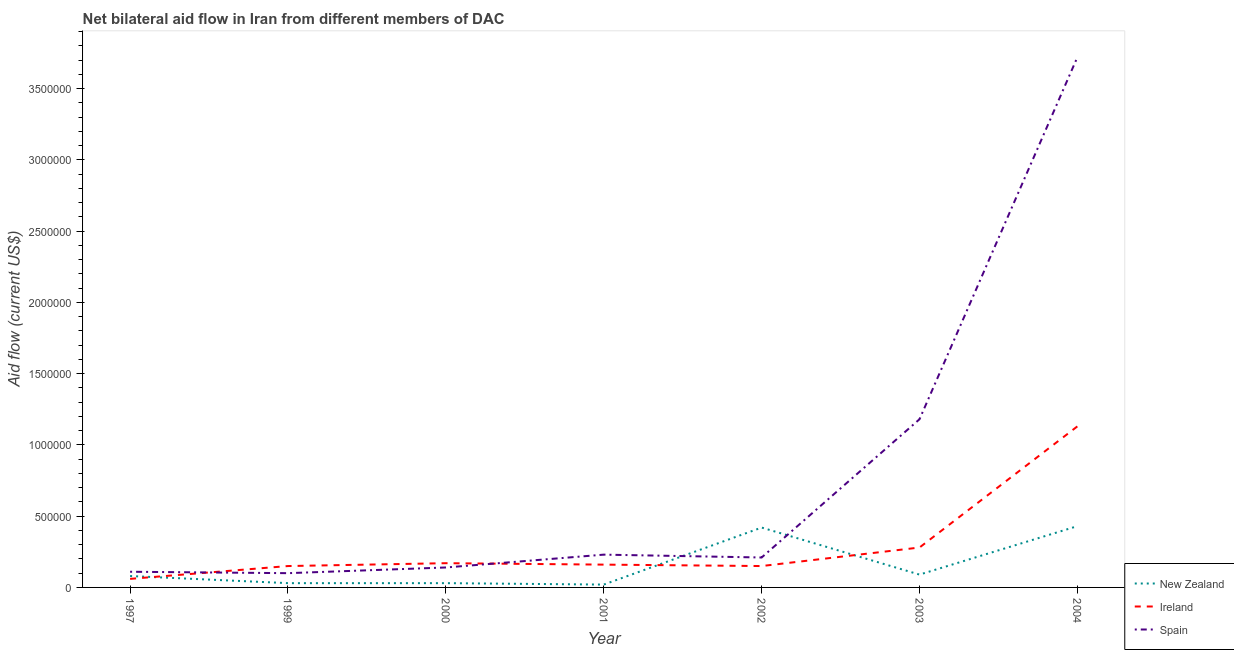How many different coloured lines are there?
Your response must be concise. 3. Does the line corresponding to amount of aid provided by ireland intersect with the line corresponding to amount of aid provided by spain?
Make the answer very short. Yes. What is the amount of aid provided by ireland in 1999?
Provide a succinct answer. 1.50e+05. Across all years, what is the maximum amount of aid provided by new zealand?
Ensure brevity in your answer.  4.30e+05. Across all years, what is the minimum amount of aid provided by new zealand?
Offer a terse response. 2.00e+04. In which year was the amount of aid provided by ireland minimum?
Your answer should be compact. 1997. What is the total amount of aid provided by ireland in the graph?
Offer a very short reply. 2.10e+06. What is the difference between the amount of aid provided by spain in 1997 and that in 2000?
Give a very brief answer. -3.00e+04. What is the difference between the amount of aid provided by new zealand in 1997 and the amount of aid provided by ireland in 2002?
Provide a short and direct response. -7.00e+04. What is the average amount of aid provided by new zealand per year?
Keep it short and to the point. 1.57e+05. In the year 2001, what is the difference between the amount of aid provided by new zealand and amount of aid provided by spain?
Provide a short and direct response. -2.10e+05. In how many years, is the amount of aid provided by ireland greater than 200000 US$?
Your response must be concise. 2. What is the ratio of the amount of aid provided by spain in 1999 to that in 2002?
Offer a terse response. 0.48. Is the amount of aid provided by ireland in 1999 less than that in 2000?
Ensure brevity in your answer.  Yes. Is the difference between the amount of aid provided by ireland in 1999 and 2004 greater than the difference between the amount of aid provided by spain in 1999 and 2004?
Offer a very short reply. Yes. What is the difference between the highest and the second highest amount of aid provided by spain?
Give a very brief answer. 2.54e+06. What is the difference between the highest and the lowest amount of aid provided by ireland?
Keep it short and to the point. 1.07e+06. Is the sum of the amount of aid provided by new zealand in 2000 and 2002 greater than the maximum amount of aid provided by spain across all years?
Your answer should be very brief. No. Does the amount of aid provided by ireland monotonically increase over the years?
Ensure brevity in your answer.  No. Is the amount of aid provided by new zealand strictly less than the amount of aid provided by spain over the years?
Your answer should be compact. No. Does the graph contain any zero values?
Your answer should be compact. No. Does the graph contain grids?
Keep it short and to the point. No. Where does the legend appear in the graph?
Keep it short and to the point. Bottom right. How many legend labels are there?
Offer a very short reply. 3. What is the title of the graph?
Keep it short and to the point. Net bilateral aid flow in Iran from different members of DAC. Does "Ireland" appear as one of the legend labels in the graph?
Your response must be concise. Yes. What is the label or title of the Y-axis?
Keep it short and to the point. Aid flow (current US$). What is the Aid flow (current US$) of New Zealand in 1997?
Offer a terse response. 8.00e+04. What is the Aid flow (current US$) of Ireland in 1997?
Give a very brief answer. 6.00e+04. What is the Aid flow (current US$) of Ireland in 1999?
Provide a succinct answer. 1.50e+05. What is the Aid flow (current US$) of Spain in 1999?
Your answer should be very brief. 1.00e+05. What is the Aid flow (current US$) in New Zealand in 2001?
Your response must be concise. 2.00e+04. What is the Aid flow (current US$) of Ireland in 2001?
Your answer should be compact. 1.60e+05. What is the Aid flow (current US$) of New Zealand in 2002?
Your response must be concise. 4.20e+05. What is the Aid flow (current US$) of Ireland in 2002?
Offer a terse response. 1.50e+05. What is the Aid flow (current US$) of Spain in 2002?
Make the answer very short. 2.10e+05. What is the Aid flow (current US$) of New Zealand in 2003?
Your response must be concise. 9.00e+04. What is the Aid flow (current US$) of Ireland in 2003?
Make the answer very short. 2.80e+05. What is the Aid flow (current US$) in Spain in 2003?
Ensure brevity in your answer.  1.18e+06. What is the Aid flow (current US$) of Ireland in 2004?
Provide a short and direct response. 1.13e+06. What is the Aid flow (current US$) in Spain in 2004?
Your response must be concise. 3.72e+06. Across all years, what is the maximum Aid flow (current US$) of New Zealand?
Offer a very short reply. 4.30e+05. Across all years, what is the maximum Aid flow (current US$) in Ireland?
Provide a succinct answer. 1.13e+06. Across all years, what is the maximum Aid flow (current US$) in Spain?
Your response must be concise. 3.72e+06. Across all years, what is the minimum Aid flow (current US$) of Ireland?
Offer a terse response. 6.00e+04. What is the total Aid flow (current US$) in New Zealand in the graph?
Provide a short and direct response. 1.10e+06. What is the total Aid flow (current US$) of Ireland in the graph?
Give a very brief answer. 2.10e+06. What is the total Aid flow (current US$) in Spain in the graph?
Keep it short and to the point. 5.69e+06. What is the difference between the Aid flow (current US$) in Ireland in 1997 and that in 1999?
Your answer should be very brief. -9.00e+04. What is the difference between the Aid flow (current US$) of New Zealand in 1997 and that in 2000?
Your answer should be very brief. 5.00e+04. What is the difference between the Aid flow (current US$) of Spain in 1997 and that in 2000?
Your answer should be very brief. -3.00e+04. What is the difference between the Aid flow (current US$) of New Zealand in 1997 and that in 2001?
Give a very brief answer. 6.00e+04. What is the difference between the Aid flow (current US$) in Ireland in 1997 and that in 2001?
Offer a very short reply. -1.00e+05. What is the difference between the Aid flow (current US$) of Spain in 1997 and that in 2001?
Offer a terse response. -1.20e+05. What is the difference between the Aid flow (current US$) of Spain in 1997 and that in 2002?
Give a very brief answer. -1.00e+05. What is the difference between the Aid flow (current US$) of Ireland in 1997 and that in 2003?
Provide a short and direct response. -2.20e+05. What is the difference between the Aid flow (current US$) of Spain in 1997 and that in 2003?
Your answer should be very brief. -1.07e+06. What is the difference between the Aid flow (current US$) in New Zealand in 1997 and that in 2004?
Keep it short and to the point. -3.50e+05. What is the difference between the Aid flow (current US$) in Ireland in 1997 and that in 2004?
Offer a terse response. -1.07e+06. What is the difference between the Aid flow (current US$) in Spain in 1997 and that in 2004?
Ensure brevity in your answer.  -3.61e+06. What is the difference between the Aid flow (current US$) in New Zealand in 1999 and that in 2000?
Your answer should be compact. 0. What is the difference between the Aid flow (current US$) of Ireland in 1999 and that in 2000?
Offer a very short reply. -2.00e+04. What is the difference between the Aid flow (current US$) in Spain in 1999 and that in 2000?
Provide a short and direct response. -4.00e+04. What is the difference between the Aid flow (current US$) in New Zealand in 1999 and that in 2001?
Your answer should be very brief. 10000. What is the difference between the Aid flow (current US$) of Spain in 1999 and that in 2001?
Give a very brief answer. -1.30e+05. What is the difference between the Aid flow (current US$) of New Zealand in 1999 and that in 2002?
Your answer should be compact. -3.90e+05. What is the difference between the Aid flow (current US$) of Ireland in 1999 and that in 2002?
Your answer should be very brief. 0. What is the difference between the Aid flow (current US$) in Spain in 1999 and that in 2002?
Your answer should be very brief. -1.10e+05. What is the difference between the Aid flow (current US$) of New Zealand in 1999 and that in 2003?
Keep it short and to the point. -6.00e+04. What is the difference between the Aid flow (current US$) of Spain in 1999 and that in 2003?
Your answer should be compact. -1.08e+06. What is the difference between the Aid flow (current US$) in New Zealand in 1999 and that in 2004?
Offer a very short reply. -4.00e+05. What is the difference between the Aid flow (current US$) in Ireland in 1999 and that in 2004?
Your answer should be very brief. -9.80e+05. What is the difference between the Aid flow (current US$) in Spain in 1999 and that in 2004?
Give a very brief answer. -3.62e+06. What is the difference between the Aid flow (current US$) of Ireland in 2000 and that in 2001?
Offer a very short reply. 10000. What is the difference between the Aid flow (current US$) of Spain in 2000 and that in 2001?
Your answer should be very brief. -9.00e+04. What is the difference between the Aid flow (current US$) of New Zealand in 2000 and that in 2002?
Your response must be concise. -3.90e+05. What is the difference between the Aid flow (current US$) of New Zealand in 2000 and that in 2003?
Provide a short and direct response. -6.00e+04. What is the difference between the Aid flow (current US$) of Ireland in 2000 and that in 2003?
Provide a short and direct response. -1.10e+05. What is the difference between the Aid flow (current US$) in Spain in 2000 and that in 2003?
Keep it short and to the point. -1.04e+06. What is the difference between the Aid flow (current US$) in New Zealand in 2000 and that in 2004?
Give a very brief answer. -4.00e+05. What is the difference between the Aid flow (current US$) in Ireland in 2000 and that in 2004?
Ensure brevity in your answer.  -9.60e+05. What is the difference between the Aid flow (current US$) in Spain in 2000 and that in 2004?
Provide a short and direct response. -3.58e+06. What is the difference between the Aid flow (current US$) in New Zealand in 2001 and that in 2002?
Your answer should be very brief. -4.00e+05. What is the difference between the Aid flow (current US$) of Ireland in 2001 and that in 2003?
Give a very brief answer. -1.20e+05. What is the difference between the Aid flow (current US$) of Spain in 2001 and that in 2003?
Provide a succinct answer. -9.50e+05. What is the difference between the Aid flow (current US$) of New Zealand in 2001 and that in 2004?
Provide a succinct answer. -4.10e+05. What is the difference between the Aid flow (current US$) of Ireland in 2001 and that in 2004?
Your answer should be very brief. -9.70e+05. What is the difference between the Aid flow (current US$) of Spain in 2001 and that in 2004?
Give a very brief answer. -3.49e+06. What is the difference between the Aid flow (current US$) in New Zealand in 2002 and that in 2003?
Your answer should be very brief. 3.30e+05. What is the difference between the Aid flow (current US$) of Spain in 2002 and that in 2003?
Ensure brevity in your answer.  -9.70e+05. What is the difference between the Aid flow (current US$) in Ireland in 2002 and that in 2004?
Give a very brief answer. -9.80e+05. What is the difference between the Aid flow (current US$) of Spain in 2002 and that in 2004?
Provide a short and direct response. -3.51e+06. What is the difference between the Aid flow (current US$) of New Zealand in 2003 and that in 2004?
Your answer should be compact. -3.40e+05. What is the difference between the Aid flow (current US$) in Ireland in 2003 and that in 2004?
Provide a short and direct response. -8.50e+05. What is the difference between the Aid flow (current US$) of Spain in 2003 and that in 2004?
Provide a succinct answer. -2.54e+06. What is the difference between the Aid flow (current US$) in New Zealand in 1997 and the Aid flow (current US$) in Spain in 2000?
Offer a terse response. -6.00e+04. What is the difference between the Aid flow (current US$) of New Zealand in 1997 and the Aid flow (current US$) of Spain in 2001?
Offer a very short reply. -1.50e+05. What is the difference between the Aid flow (current US$) in New Zealand in 1997 and the Aid flow (current US$) in Ireland in 2002?
Your response must be concise. -7.00e+04. What is the difference between the Aid flow (current US$) of New Zealand in 1997 and the Aid flow (current US$) of Ireland in 2003?
Keep it short and to the point. -2.00e+05. What is the difference between the Aid flow (current US$) in New Zealand in 1997 and the Aid flow (current US$) in Spain in 2003?
Provide a succinct answer. -1.10e+06. What is the difference between the Aid flow (current US$) of Ireland in 1997 and the Aid flow (current US$) of Spain in 2003?
Offer a terse response. -1.12e+06. What is the difference between the Aid flow (current US$) in New Zealand in 1997 and the Aid flow (current US$) in Ireland in 2004?
Your answer should be very brief. -1.05e+06. What is the difference between the Aid flow (current US$) of New Zealand in 1997 and the Aid flow (current US$) of Spain in 2004?
Keep it short and to the point. -3.64e+06. What is the difference between the Aid flow (current US$) of Ireland in 1997 and the Aid flow (current US$) of Spain in 2004?
Your answer should be compact. -3.66e+06. What is the difference between the Aid flow (current US$) of Ireland in 1999 and the Aid flow (current US$) of Spain in 2000?
Your answer should be compact. 10000. What is the difference between the Aid flow (current US$) in New Zealand in 1999 and the Aid flow (current US$) in Ireland in 2001?
Provide a short and direct response. -1.30e+05. What is the difference between the Aid flow (current US$) of New Zealand in 1999 and the Aid flow (current US$) of Spain in 2001?
Provide a short and direct response. -2.00e+05. What is the difference between the Aid flow (current US$) of New Zealand in 1999 and the Aid flow (current US$) of Ireland in 2002?
Provide a succinct answer. -1.20e+05. What is the difference between the Aid flow (current US$) in Ireland in 1999 and the Aid flow (current US$) in Spain in 2002?
Keep it short and to the point. -6.00e+04. What is the difference between the Aid flow (current US$) of New Zealand in 1999 and the Aid flow (current US$) of Spain in 2003?
Offer a very short reply. -1.15e+06. What is the difference between the Aid flow (current US$) in Ireland in 1999 and the Aid flow (current US$) in Spain in 2003?
Offer a very short reply. -1.03e+06. What is the difference between the Aid flow (current US$) of New Zealand in 1999 and the Aid flow (current US$) of Ireland in 2004?
Keep it short and to the point. -1.10e+06. What is the difference between the Aid flow (current US$) in New Zealand in 1999 and the Aid flow (current US$) in Spain in 2004?
Offer a terse response. -3.69e+06. What is the difference between the Aid flow (current US$) of Ireland in 1999 and the Aid flow (current US$) of Spain in 2004?
Offer a very short reply. -3.57e+06. What is the difference between the Aid flow (current US$) in New Zealand in 2000 and the Aid flow (current US$) in Spain in 2001?
Make the answer very short. -2.00e+05. What is the difference between the Aid flow (current US$) in Ireland in 2000 and the Aid flow (current US$) in Spain in 2002?
Make the answer very short. -4.00e+04. What is the difference between the Aid flow (current US$) of New Zealand in 2000 and the Aid flow (current US$) of Ireland in 2003?
Provide a succinct answer. -2.50e+05. What is the difference between the Aid flow (current US$) of New Zealand in 2000 and the Aid flow (current US$) of Spain in 2003?
Your answer should be very brief. -1.15e+06. What is the difference between the Aid flow (current US$) of Ireland in 2000 and the Aid flow (current US$) of Spain in 2003?
Offer a terse response. -1.01e+06. What is the difference between the Aid flow (current US$) of New Zealand in 2000 and the Aid flow (current US$) of Ireland in 2004?
Offer a terse response. -1.10e+06. What is the difference between the Aid flow (current US$) in New Zealand in 2000 and the Aid flow (current US$) in Spain in 2004?
Your answer should be very brief. -3.69e+06. What is the difference between the Aid flow (current US$) in Ireland in 2000 and the Aid flow (current US$) in Spain in 2004?
Your response must be concise. -3.55e+06. What is the difference between the Aid flow (current US$) in New Zealand in 2001 and the Aid flow (current US$) in Ireland in 2002?
Keep it short and to the point. -1.30e+05. What is the difference between the Aid flow (current US$) of New Zealand in 2001 and the Aid flow (current US$) of Spain in 2002?
Make the answer very short. -1.90e+05. What is the difference between the Aid flow (current US$) of Ireland in 2001 and the Aid flow (current US$) of Spain in 2002?
Give a very brief answer. -5.00e+04. What is the difference between the Aid flow (current US$) in New Zealand in 2001 and the Aid flow (current US$) in Spain in 2003?
Ensure brevity in your answer.  -1.16e+06. What is the difference between the Aid flow (current US$) in Ireland in 2001 and the Aid flow (current US$) in Spain in 2003?
Offer a terse response. -1.02e+06. What is the difference between the Aid flow (current US$) in New Zealand in 2001 and the Aid flow (current US$) in Ireland in 2004?
Keep it short and to the point. -1.11e+06. What is the difference between the Aid flow (current US$) in New Zealand in 2001 and the Aid flow (current US$) in Spain in 2004?
Your response must be concise. -3.70e+06. What is the difference between the Aid flow (current US$) in Ireland in 2001 and the Aid flow (current US$) in Spain in 2004?
Offer a terse response. -3.56e+06. What is the difference between the Aid flow (current US$) in New Zealand in 2002 and the Aid flow (current US$) in Spain in 2003?
Give a very brief answer. -7.60e+05. What is the difference between the Aid flow (current US$) in Ireland in 2002 and the Aid flow (current US$) in Spain in 2003?
Give a very brief answer. -1.03e+06. What is the difference between the Aid flow (current US$) in New Zealand in 2002 and the Aid flow (current US$) in Ireland in 2004?
Offer a terse response. -7.10e+05. What is the difference between the Aid flow (current US$) in New Zealand in 2002 and the Aid flow (current US$) in Spain in 2004?
Make the answer very short. -3.30e+06. What is the difference between the Aid flow (current US$) of Ireland in 2002 and the Aid flow (current US$) of Spain in 2004?
Your answer should be compact. -3.57e+06. What is the difference between the Aid flow (current US$) of New Zealand in 2003 and the Aid flow (current US$) of Ireland in 2004?
Ensure brevity in your answer.  -1.04e+06. What is the difference between the Aid flow (current US$) in New Zealand in 2003 and the Aid flow (current US$) in Spain in 2004?
Keep it short and to the point. -3.63e+06. What is the difference between the Aid flow (current US$) in Ireland in 2003 and the Aid flow (current US$) in Spain in 2004?
Provide a succinct answer. -3.44e+06. What is the average Aid flow (current US$) in New Zealand per year?
Ensure brevity in your answer.  1.57e+05. What is the average Aid flow (current US$) of Ireland per year?
Give a very brief answer. 3.00e+05. What is the average Aid flow (current US$) in Spain per year?
Provide a succinct answer. 8.13e+05. In the year 1997, what is the difference between the Aid flow (current US$) in New Zealand and Aid flow (current US$) in Spain?
Your answer should be compact. -3.00e+04. In the year 1997, what is the difference between the Aid flow (current US$) of Ireland and Aid flow (current US$) of Spain?
Give a very brief answer. -5.00e+04. In the year 2000, what is the difference between the Aid flow (current US$) in New Zealand and Aid flow (current US$) in Spain?
Ensure brevity in your answer.  -1.10e+05. In the year 2000, what is the difference between the Aid flow (current US$) of Ireland and Aid flow (current US$) of Spain?
Offer a terse response. 3.00e+04. In the year 2001, what is the difference between the Aid flow (current US$) in New Zealand and Aid flow (current US$) in Spain?
Make the answer very short. -2.10e+05. In the year 2002, what is the difference between the Aid flow (current US$) of New Zealand and Aid flow (current US$) of Spain?
Offer a terse response. 2.10e+05. In the year 2003, what is the difference between the Aid flow (current US$) of New Zealand and Aid flow (current US$) of Ireland?
Make the answer very short. -1.90e+05. In the year 2003, what is the difference between the Aid flow (current US$) in New Zealand and Aid flow (current US$) in Spain?
Provide a succinct answer. -1.09e+06. In the year 2003, what is the difference between the Aid flow (current US$) in Ireland and Aid flow (current US$) in Spain?
Your response must be concise. -9.00e+05. In the year 2004, what is the difference between the Aid flow (current US$) of New Zealand and Aid flow (current US$) of Ireland?
Make the answer very short. -7.00e+05. In the year 2004, what is the difference between the Aid flow (current US$) in New Zealand and Aid flow (current US$) in Spain?
Provide a succinct answer. -3.29e+06. In the year 2004, what is the difference between the Aid flow (current US$) of Ireland and Aid flow (current US$) of Spain?
Keep it short and to the point. -2.59e+06. What is the ratio of the Aid flow (current US$) of New Zealand in 1997 to that in 1999?
Your response must be concise. 2.67. What is the ratio of the Aid flow (current US$) of Ireland in 1997 to that in 1999?
Keep it short and to the point. 0.4. What is the ratio of the Aid flow (current US$) in New Zealand in 1997 to that in 2000?
Provide a short and direct response. 2.67. What is the ratio of the Aid flow (current US$) in Ireland in 1997 to that in 2000?
Offer a very short reply. 0.35. What is the ratio of the Aid flow (current US$) of Spain in 1997 to that in 2000?
Give a very brief answer. 0.79. What is the ratio of the Aid flow (current US$) in New Zealand in 1997 to that in 2001?
Provide a short and direct response. 4. What is the ratio of the Aid flow (current US$) in Spain in 1997 to that in 2001?
Ensure brevity in your answer.  0.48. What is the ratio of the Aid flow (current US$) of New Zealand in 1997 to that in 2002?
Give a very brief answer. 0.19. What is the ratio of the Aid flow (current US$) of Spain in 1997 to that in 2002?
Offer a very short reply. 0.52. What is the ratio of the Aid flow (current US$) of New Zealand in 1997 to that in 2003?
Your response must be concise. 0.89. What is the ratio of the Aid flow (current US$) of Ireland in 1997 to that in 2003?
Offer a very short reply. 0.21. What is the ratio of the Aid flow (current US$) in Spain in 1997 to that in 2003?
Your answer should be very brief. 0.09. What is the ratio of the Aid flow (current US$) of New Zealand in 1997 to that in 2004?
Offer a terse response. 0.19. What is the ratio of the Aid flow (current US$) in Ireland in 1997 to that in 2004?
Your response must be concise. 0.05. What is the ratio of the Aid flow (current US$) in Spain in 1997 to that in 2004?
Your answer should be compact. 0.03. What is the ratio of the Aid flow (current US$) in New Zealand in 1999 to that in 2000?
Provide a succinct answer. 1. What is the ratio of the Aid flow (current US$) of Ireland in 1999 to that in 2000?
Provide a short and direct response. 0.88. What is the ratio of the Aid flow (current US$) in New Zealand in 1999 to that in 2001?
Keep it short and to the point. 1.5. What is the ratio of the Aid flow (current US$) in Ireland in 1999 to that in 2001?
Provide a succinct answer. 0.94. What is the ratio of the Aid flow (current US$) of Spain in 1999 to that in 2001?
Provide a succinct answer. 0.43. What is the ratio of the Aid flow (current US$) in New Zealand in 1999 to that in 2002?
Your answer should be very brief. 0.07. What is the ratio of the Aid flow (current US$) of Ireland in 1999 to that in 2002?
Keep it short and to the point. 1. What is the ratio of the Aid flow (current US$) of Spain in 1999 to that in 2002?
Make the answer very short. 0.48. What is the ratio of the Aid flow (current US$) in Ireland in 1999 to that in 2003?
Your answer should be very brief. 0.54. What is the ratio of the Aid flow (current US$) in Spain in 1999 to that in 2003?
Offer a terse response. 0.08. What is the ratio of the Aid flow (current US$) in New Zealand in 1999 to that in 2004?
Your response must be concise. 0.07. What is the ratio of the Aid flow (current US$) in Ireland in 1999 to that in 2004?
Ensure brevity in your answer.  0.13. What is the ratio of the Aid flow (current US$) of Spain in 1999 to that in 2004?
Your response must be concise. 0.03. What is the ratio of the Aid flow (current US$) of New Zealand in 2000 to that in 2001?
Ensure brevity in your answer.  1.5. What is the ratio of the Aid flow (current US$) in Spain in 2000 to that in 2001?
Make the answer very short. 0.61. What is the ratio of the Aid flow (current US$) in New Zealand in 2000 to that in 2002?
Ensure brevity in your answer.  0.07. What is the ratio of the Aid flow (current US$) in Ireland in 2000 to that in 2002?
Your answer should be very brief. 1.13. What is the ratio of the Aid flow (current US$) of New Zealand in 2000 to that in 2003?
Keep it short and to the point. 0.33. What is the ratio of the Aid flow (current US$) in Ireland in 2000 to that in 2003?
Offer a terse response. 0.61. What is the ratio of the Aid flow (current US$) of Spain in 2000 to that in 2003?
Provide a short and direct response. 0.12. What is the ratio of the Aid flow (current US$) in New Zealand in 2000 to that in 2004?
Provide a succinct answer. 0.07. What is the ratio of the Aid flow (current US$) of Ireland in 2000 to that in 2004?
Your answer should be compact. 0.15. What is the ratio of the Aid flow (current US$) in Spain in 2000 to that in 2004?
Your answer should be very brief. 0.04. What is the ratio of the Aid flow (current US$) in New Zealand in 2001 to that in 2002?
Provide a succinct answer. 0.05. What is the ratio of the Aid flow (current US$) of Ireland in 2001 to that in 2002?
Make the answer very short. 1.07. What is the ratio of the Aid flow (current US$) in Spain in 2001 to that in 2002?
Your answer should be compact. 1.1. What is the ratio of the Aid flow (current US$) of New Zealand in 2001 to that in 2003?
Provide a succinct answer. 0.22. What is the ratio of the Aid flow (current US$) in Spain in 2001 to that in 2003?
Provide a succinct answer. 0.19. What is the ratio of the Aid flow (current US$) of New Zealand in 2001 to that in 2004?
Provide a short and direct response. 0.05. What is the ratio of the Aid flow (current US$) of Ireland in 2001 to that in 2004?
Keep it short and to the point. 0.14. What is the ratio of the Aid flow (current US$) in Spain in 2001 to that in 2004?
Offer a terse response. 0.06. What is the ratio of the Aid flow (current US$) of New Zealand in 2002 to that in 2003?
Give a very brief answer. 4.67. What is the ratio of the Aid flow (current US$) of Ireland in 2002 to that in 2003?
Your answer should be very brief. 0.54. What is the ratio of the Aid flow (current US$) of Spain in 2002 to that in 2003?
Your response must be concise. 0.18. What is the ratio of the Aid flow (current US$) of New Zealand in 2002 to that in 2004?
Make the answer very short. 0.98. What is the ratio of the Aid flow (current US$) in Ireland in 2002 to that in 2004?
Your answer should be compact. 0.13. What is the ratio of the Aid flow (current US$) in Spain in 2002 to that in 2004?
Offer a very short reply. 0.06. What is the ratio of the Aid flow (current US$) of New Zealand in 2003 to that in 2004?
Ensure brevity in your answer.  0.21. What is the ratio of the Aid flow (current US$) in Ireland in 2003 to that in 2004?
Your response must be concise. 0.25. What is the ratio of the Aid flow (current US$) in Spain in 2003 to that in 2004?
Give a very brief answer. 0.32. What is the difference between the highest and the second highest Aid flow (current US$) in New Zealand?
Your response must be concise. 10000. What is the difference between the highest and the second highest Aid flow (current US$) of Ireland?
Make the answer very short. 8.50e+05. What is the difference between the highest and the second highest Aid flow (current US$) of Spain?
Make the answer very short. 2.54e+06. What is the difference between the highest and the lowest Aid flow (current US$) in New Zealand?
Your response must be concise. 4.10e+05. What is the difference between the highest and the lowest Aid flow (current US$) of Ireland?
Your response must be concise. 1.07e+06. What is the difference between the highest and the lowest Aid flow (current US$) of Spain?
Your answer should be very brief. 3.62e+06. 